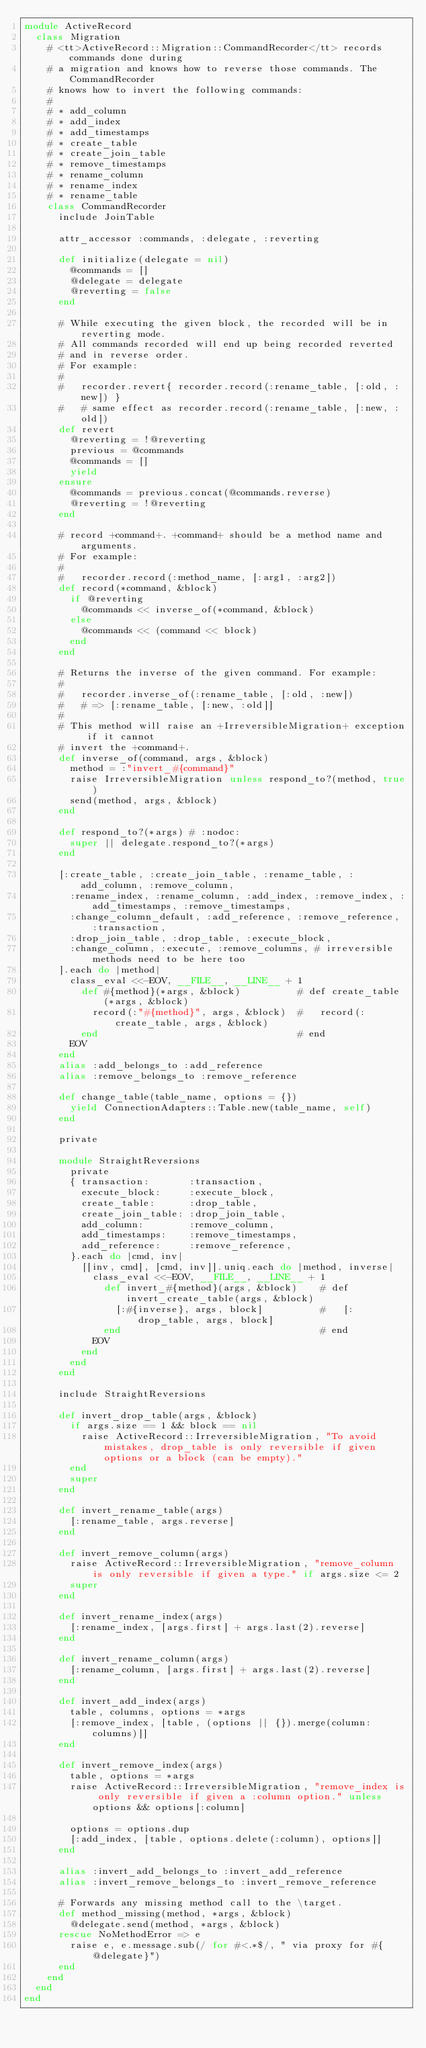Convert code to text. <code><loc_0><loc_0><loc_500><loc_500><_Ruby_>module ActiveRecord
  class Migration
    # <tt>ActiveRecord::Migration::CommandRecorder</tt> records commands done during
    # a migration and knows how to reverse those commands. The CommandRecorder
    # knows how to invert the following commands:
    #
    # * add_column
    # * add_index
    # * add_timestamps
    # * create_table
    # * create_join_table
    # * remove_timestamps
    # * rename_column
    # * rename_index
    # * rename_table
    class CommandRecorder
      include JoinTable

      attr_accessor :commands, :delegate, :reverting

      def initialize(delegate = nil)
        @commands = []
        @delegate = delegate
        @reverting = false
      end

      # While executing the given block, the recorded will be in reverting mode.
      # All commands recorded will end up being recorded reverted
      # and in reverse order.
      # For example:
      #
      #   recorder.revert{ recorder.record(:rename_table, [:old, :new]) }
      #   # same effect as recorder.record(:rename_table, [:new, :old])
      def revert
        @reverting = !@reverting
        previous = @commands
        @commands = []
        yield
      ensure
        @commands = previous.concat(@commands.reverse)
        @reverting = !@reverting
      end

      # record +command+. +command+ should be a method name and arguments.
      # For example:
      #
      #   recorder.record(:method_name, [:arg1, :arg2])
      def record(*command, &block)
        if @reverting
          @commands << inverse_of(*command, &block)
        else
          @commands << (command << block)
        end
      end

      # Returns the inverse of the given command. For example:
      #
      #   recorder.inverse_of(:rename_table, [:old, :new])
      #   # => [:rename_table, [:new, :old]]
      #
      # This method will raise an +IrreversibleMigration+ exception if it cannot
      # invert the +command+.
      def inverse_of(command, args, &block)
        method = :"invert_#{command}"
        raise IrreversibleMigration unless respond_to?(method, true)
        send(method, args, &block)
      end

      def respond_to?(*args) # :nodoc:
        super || delegate.respond_to?(*args)
      end

      [:create_table, :create_join_table, :rename_table, :add_column, :remove_column,
        :rename_index, :rename_column, :add_index, :remove_index, :add_timestamps, :remove_timestamps,
        :change_column_default, :add_reference, :remove_reference, :transaction,
        :drop_join_table, :drop_table, :execute_block,
        :change_column, :execute, :remove_columns, # irreversible methods need to be here too
      ].each do |method|
        class_eval <<-EOV, __FILE__, __LINE__ + 1
          def #{method}(*args, &block)          # def create_table(*args, &block)
            record(:"#{method}", args, &block)  #   record(:create_table, args, &block)
          end                                   # end
        EOV
      end
      alias :add_belongs_to :add_reference
      alias :remove_belongs_to :remove_reference

      def change_table(table_name, options = {})
        yield ConnectionAdapters::Table.new(table_name, self)
      end

      private

      module StraightReversions
        private
        { transaction:       :transaction,
          execute_block:     :execute_block,
          create_table:      :drop_table,
          create_join_table: :drop_join_table,
          add_column:        :remove_column,
          add_timestamps:    :remove_timestamps,
          add_reference:     :remove_reference,
        }.each do |cmd, inv|
          [[inv, cmd], [cmd, inv]].uniq.each do |method, inverse|
            class_eval <<-EOV, __FILE__, __LINE__ + 1
              def invert_#{method}(args, &block)    # def invert_create_table(args, &block)
                [:#{inverse}, args, block]          #   [:drop_table, args, block]
              end                                   # end
            EOV
          end
        end
      end

      include StraightReversions

      def invert_drop_table(args, &block)
        if args.size == 1 && block == nil
          raise ActiveRecord::IrreversibleMigration, "To avoid mistakes, drop_table is only reversible if given options or a block (can be empty)."
        end
        super
      end

      def invert_rename_table(args)
        [:rename_table, args.reverse]
      end

      def invert_remove_column(args)
        raise ActiveRecord::IrreversibleMigration, "remove_column is only reversible if given a type." if args.size <= 2
        super
      end

      def invert_rename_index(args)
        [:rename_index, [args.first] + args.last(2).reverse]
      end

      def invert_rename_column(args)
        [:rename_column, [args.first] + args.last(2).reverse]
      end

      def invert_add_index(args)
        table, columns, options = *args
        [:remove_index, [table, (options || {}).merge(column: columns)]]
      end

      def invert_remove_index(args)
        table, options = *args
        raise ActiveRecord::IrreversibleMigration, "remove_index is only reversible if given a :column option." unless options && options[:column]

        options = options.dup
        [:add_index, [table, options.delete(:column), options]]
      end

      alias :invert_add_belongs_to :invert_add_reference
      alias :invert_remove_belongs_to :invert_remove_reference

      # Forwards any missing method call to the \target.
      def method_missing(method, *args, &block)
        @delegate.send(method, *args, &block)
      rescue NoMethodError => e
        raise e, e.message.sub(/ for #<.*$/, " via proxy for #{@delegate}")
      end
    end
  end
end
</code> 